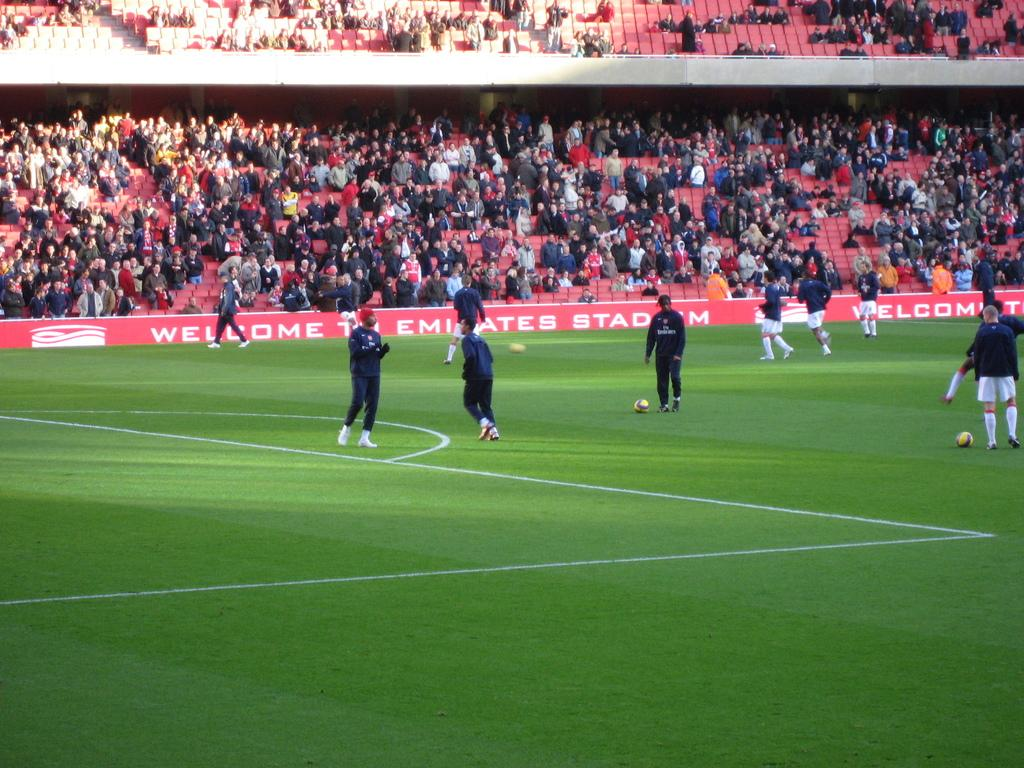What are the players in the image doing? The players in the image are playing on the ground. Can you describe the setting of the image? In the background, there are people sitting and standing, watching the game. What might the people in the background be doing? The people in the background are watching the game. What song is the tramp singing in the image? There is no tramp or singing in the image; it features players playing on the ground and people watching the game. 